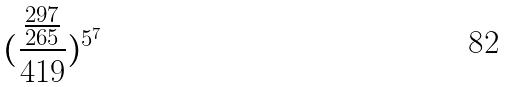<formula> <loc_0><loc_0><loc_500><loc_500>( \frac { \frac { 2 9 7 } { 2 6 5 } } { 4 1 9 } ) ^ { 5 ^ { 7 } }</formula> 